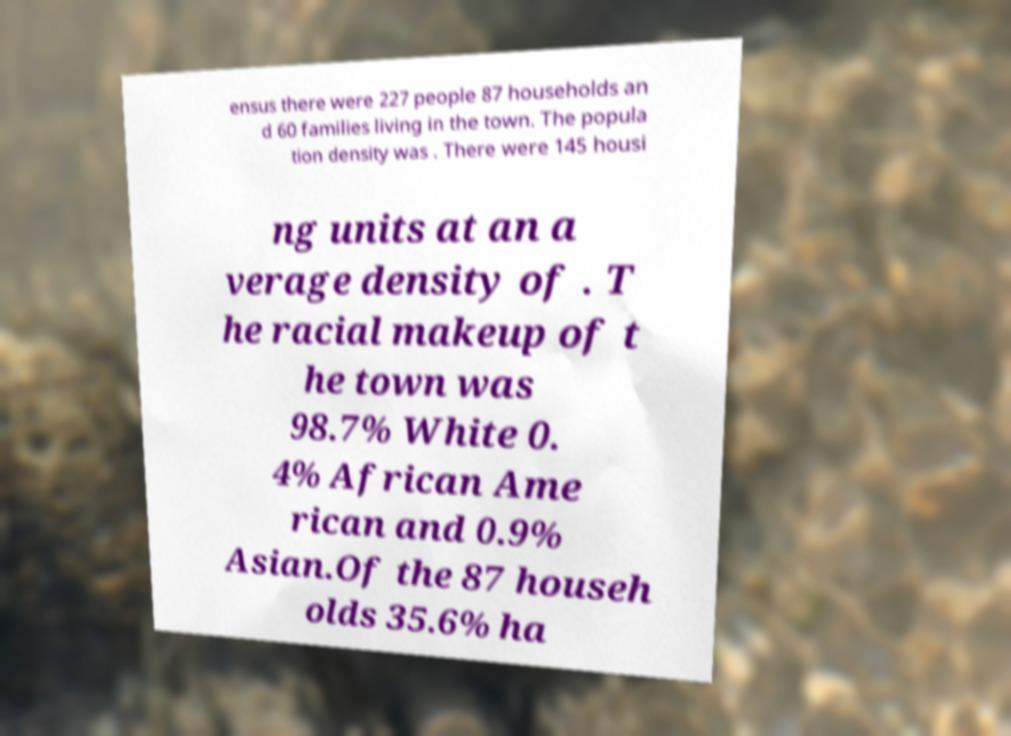Could you extract and type out the text from this image? ensus there were 227 people 87 households an d 60 families living in the town. The popula tion density was . There were 145 housi ng units at an a verage density of . T he racial makeup of t he town was 98.7% White 0. 4% African Ame rican and 0.9% Asian.Of the 87 househ olds 35.6% ha 